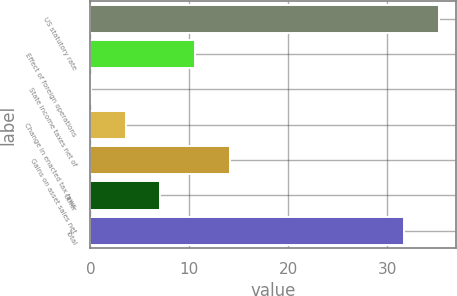<chart> <loc_0><loc_0><loc_500><loc_500><bar_chart><fcel>US statutory rate<fcel>Effect of foreign operations<fcel>State income taxes net of<fcel>Change in enacted tax laws<fcel>Gains on asset sales net<fcel>Other<fcel>Total<nl><fcel>35.19<fcel>10.57<fcel>0.1<fcel>3.59<fcel>14.06<fcel>7.08<fcel>31.7<nl></chart> 